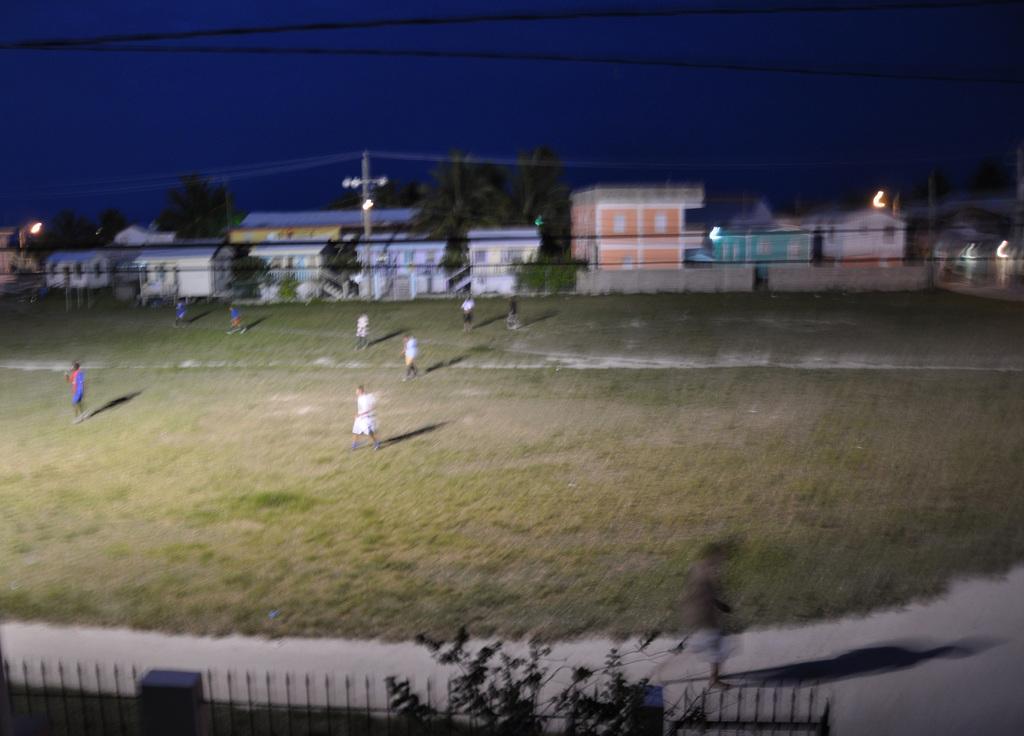Can you describe this image briefly? In this picture we can see a group of people standing on the ground and in the background we can see buildings,trees,sky. 